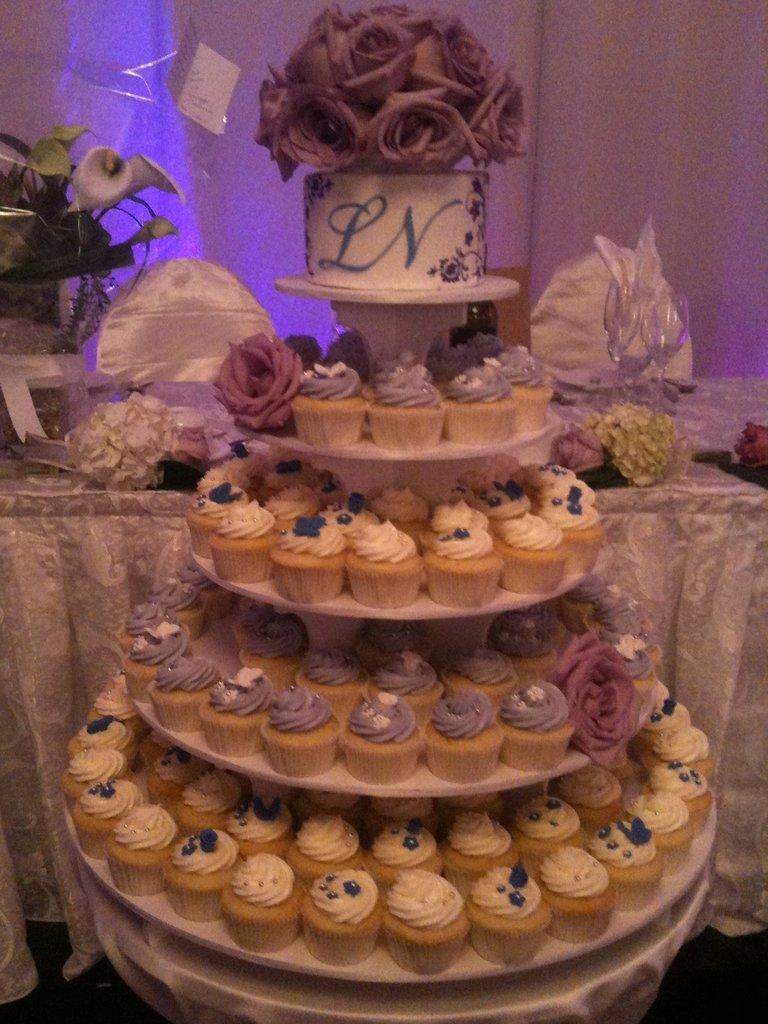Please provide a concise description of this image. In the image in the center, we can see one cake. On the cake, we can see cupcakes, flowers, etc. In the background there is a wall, table, cloth, glass, hat, flower and a few other objects. 